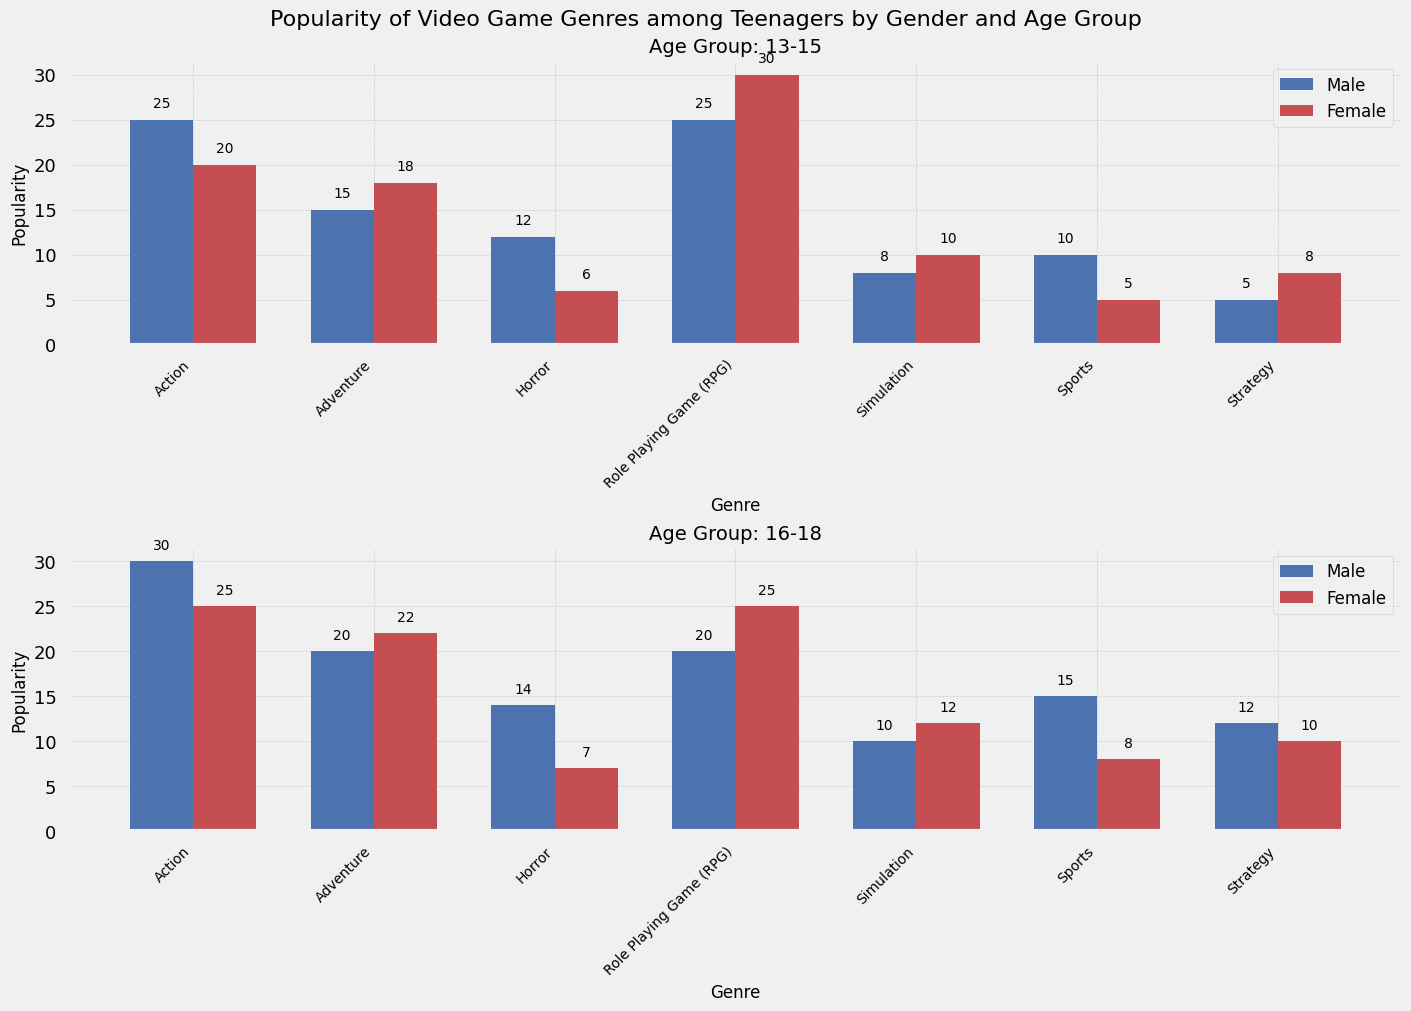Which genre is most popular among 13-15-year-old males? From the bar chart, look at the bars for 13-15-year-old males and identify the highest one. The highest bar corresponds to the popularity of Role Playing Game (RPG) with a value of 25.
Answer: Role Playing Game (RPG) Which age group prefers Action games more, males aged 13-15 or females aged 16-18? Compare the height of the Action genre bars for both groups. Males aged 13-15 have a value of 25, while females aged 16-18 have a value of 25. Since the values are equal, both groups prefer Action games equally.
Answer: Both equally What is the total popularity of Strategy games among 16-18-year-olds? Find the popularity values for Strategy games among 16-18-year-old males and females, and sum them up. The values are 12 for males and 10 for females. Therefore, the total popularity is 12 + 10 = 22.
Answer: 22 Which gender in the 16-18 age group has a higher preference for Horror games? Compare the height of the Horror genre bars for males and females aged 16-18. Males have a value of 14, and females have a value of 7. Since 14 is greater than 7, males have a higher preference.
Answer: Males Are Simulation games more popular among females aged 13-15 or 16-18? Compare the height of the Simulation genre bars for females aged 13-15 and 16-18. The values are 10 for 13-15 and 12 for 16-18. Since 12 is greater than 10, females aged 16-18 prefer Simulation games more.
Answer: 16-18 Which genre has the smallest gender difference in popularity among 13-15-year-olds? Calculate the absolute difference in popularity for each genre between males and females aged 13-15. The differences are: Action (5), Adventure (3), Sports (5), Strategy (3), Simulation (2), Horror (6), RPG (5). Simulation has the smallest difference, which is 2.
Answer: Simulation What is the average popularity of Adventure games for all groups combined? First, find the popularity values for Adventure games across all groups: (15, 18, 20, 22). Then calculate the average: (15 + 18 + 20 + 22) / 4 = 75 / 4 = 18.75.
Answer: 18.75 Which genre is least popular among females aged 13-15? Look at the bars for each genre among females aged 13-15 and identify the shortest one. The shortest bar is for Sports with a value of 5.
Answer: Sports 